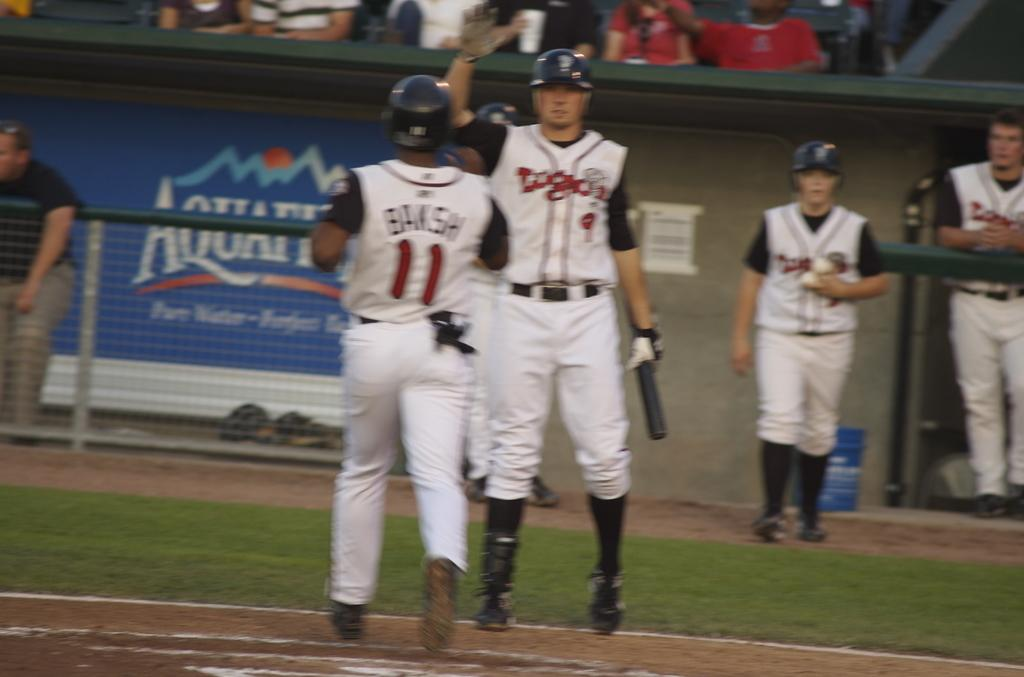<image>
Provide a brief description of the given image. Baseball player number 9 holds his hand up to high five player 11. 